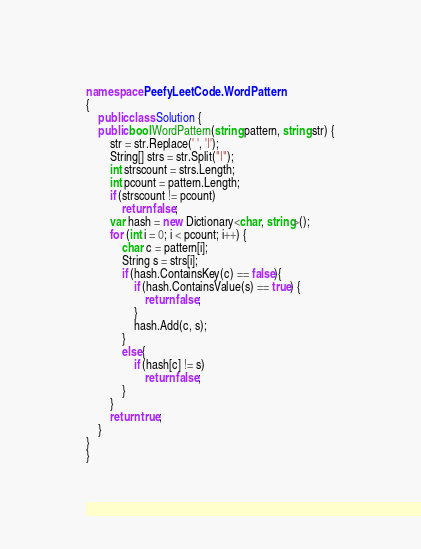Convert code to text. <code><loc_0><loc_0><loc_500><loc_500><_C#_>
namespace PeefyLeetCode.WordPattern
{
    public class Solution {
    public bool WordPattern(string pattern, string str) {
        str = str.Replace(' ', '|');
        String[] strs = str.Split("|");
        int strscount = strs.Length;
        int pcount = pattern.Length;
        if (strscount != pcount)
            return false;
        var hash = new Dictionary<char, string>();
        for (int i = 0; i < pcount; i++) {
            char c = pattern[i];
            String s = strs[i];
            if (hash.ContainsKey(c) == false){
                if (hash.ContainsValue(s) == true) {
                    return false;
                }
                hash.Add(c, s);
            }
            else{
                if (hash[c] != s)
                    return false;
            }
        }
        return true;
    }
}
}</code> 